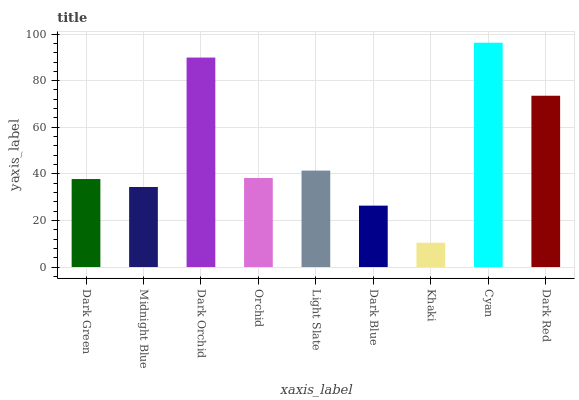Is Midnight Blue the minimum?
Answer yes or no. No. Is Midnight Blue the maximum?
Answer yes or no. No. Is Dark Green greater than Midnight Blue?
Answer yes or no. Yes. Is Midnight Blue less than Dark Green?
Answer yes or no. Yes. Is Midnight Blue greater than Dark Green?
Answer yes or no. No. Is Dark Green less than Midnight Blue?
Answer yes or no. No. Is Orchid the high median?
Answer yes or no. Yes. Is Orchid the low median?
Answer yes or no. Yes. Is Midnight Blue the high median?
Answer yes or no. No. Is Dark Blue the low median?
Answer yes or no. No. 